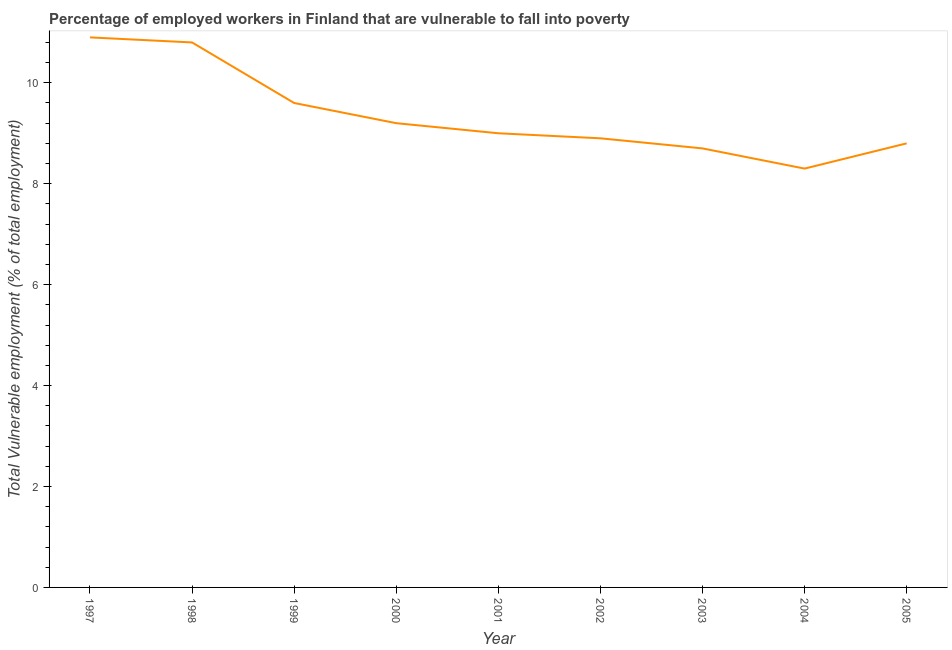Across all years, what is the maximum total vulnerable employment?
Provide a succinct answer. 10.9. Across all years, what is the minimum total vulnerable employment?
Your answer should be very brief. 8.3. What is the sum of the total vulnerable employment?
Provide a short and direct response. 84.2. What is the difference between the total vulnerable employment in 2003 and 2004?
Your answer should be compact. 0.4. What is the average total vulnerable employment per year?
Keep it short and to the point. 9.36. What is the median total vulnerable employment?
Give a very brief answer. 9. In how many years, is the total vulnerable employment greater than 9.2 %?
Make the answer very short. 3. Do a majority of the years between 1999 and 2002 (inclusive) have total vulnerable employment greater than 6.4 %?
Ensure brevity in your answer.  Yes. What is the ratio of the total vulnerable employment in 2000 to that in 2003?
Keep it short and to the point. 1.06. Is the difference between the total vulnerable employment in 1997 and 2002 greater than the difference between any two years?
Keep it short and to the point. No. What is the difference between the highest and the second highest total vulnerable employment?
Make the answer very short. 0.1. Is the sum of the total vulnerable employment in 1997 and 2001 greater than the maximum total vulnerable employment across all years?
Provide a succinct answer. Yes. What is the difference between the highest and the lowest total vulnerable employment?
Your response must be concise. 2.6. In how many years, is the total vulnerable employment greater than the average total vulnerable employment taken over all years?
Give a very brief answer. 3. How many lines are there?
Keep it short and to the point. 1. How many years are there in the graph?
Your answer should be very brief. 9. Are the values on the major ticks of Y-axis written in scientific E-notation?
Your answer should be compact. No. Does the graph contain any zero values?
Your answer should be very brief. No. What is the title of the graph?
Keep it short and to the point. Percentage of employed workers in Finland that are vulnerable to fall into poverty. What is the label or title of the Y-axis?
Provide a succinct answer. Total Vulnerable employment (% of total employment). What is the Total Vulnerable employment (% of total employment) in 1997?
Offer a very short reply. 10.9. What is the Total Vulnerable employment (% of total employment) of 1998?
Your answer should be compact. 10.8. What is the Total Vulnerable employment (% of total employment) of 1999?
Offer a very short reply. 9.6. What is the Total Vulnerable employment (% of total employment) in 2000?
Provide a short and direct response. 9.2. What is the Total Vulnerable employment (% of total employment) of 2001?
Your response must be concise. 9. What is the Total Vulnerable employment (% of total employment) of 2002?
Your answer should be very brief. 8.9. What is the Total Vulnerable employment (% of total employment) of 2003?
Offer a very short reply. 8.7. What is the Total Vulnerable employment (% of total employment) in 2004?
Provide a short and direct response. 8.3. What is the Total Vulnerable employment (% of total employment) of 2005?
Give a very brief answer. 8.8. What is the difference between the Total Vulnerable employment (% of total employment) in 1997 and 2000?
Provide a succinct answer. 1.7. What is the difference between the Total Vulnerable employment (% of total employment) in 1997 and 2001?
Give a very brief answer. 1.9. What is the difference between the Total Vulnerable employment (% of total employment) in 1997 and 2002?
Give a very brief answer. 2. What is the difference between the Total Vulnerable employment (% of total employment) in 1997 and 2004?
Your answer should be very brief. 2.6. What is the difference between the Total Vulnerable employment (% of total employment) in 1998 and 2000?
Keep it short and to the point. 1.6. What is the difference between the Total Vulnerable employment (% of total employment) in 1998 and 2001?
Your answer should be compact. 1.8. What is the difference between the Total Vulnerable employment (% of total employment) in 1998 and 2002?
Provide a short and direct response. 1.9. What is the difference between the Total Vulnerable employment (% of total employment) in 1998 and 2004?
Ensure brevity in your answer.  2.5. What is the difference between the Total Vulnerable employment (% of total employment) in 1999 and 2000?
Your response must be concise. 0.4. What is the difference between the Total Vulnerable employment (% of total employment) in 2000 and 2002?
Give a very brief answer. 0.3. What is the difference between the Total Vulnerable employment (% of total employment) in 2000 and 2004?
Offer a very short reply. 0.9. What is the difference between the Total Vulnerable employment (% of total employment) in 2001 and 2002?
Ensure brevity in your answer.  0.1. What is the difference between the Total Vulnerable employment (% of total employment) in 2001 and 2003?
Your answer should be very brief. 0.3. What is the difference between the Total Vulnerable employment (% of total employment) in 2001 and 2004?
Your response must be concise. 0.7. What is the difference between the Total Vulnerable employment (% of total employment) in 2002 and 2005?
Your response must be concise. 0.1. What is the difference between the Total Vulnerable employment (% of total employment) in 2004 and 2005?
Provide a succinct answer. -0.5. What is the ratio of the Total Vulnerable employment (% of total employment) in 1997 to that in 1999?
Ensure brevity in your answer.  1.14. What is the ratio of the Total Vulnerable employment (% of total employment) in 1997 to that in 2000?
Give a very brief answer. 1.19. What is the ratio of the Total Vulnerable employment (% of total employment) in 1997 to that in 2001?
Give a very brief answer. 1.21. What is the ratio of the Total Vulnerable employment (% of total employment) in 1997 to that in 2002?
Offer a terse response. 1.23. What is the ratio of the Total Vulnerable employment (% of total employment) in 1997 to that in 2003?
Your answer should be compact. 1.25. What is the ratio of the Total Vulnerable employment (% of total employment) in 1997 to that in 2004?
Your answer should be compact. 1.31. What is the ratio of the Total Vulnerable employment (% of total employment) in 1997 to that in 2005?
Your response must be concise. 1.24. What is the ratio of the Total Vulnerable employment (% of total employment) in 1998 to that in 1999?
Offer a terse response. 1.12. What is the ratio of the Total Vulnerable employment (% of total employment) in 1998 to that in 2000?
Your answer should be very brief. 1.17. What is the ratio of the Total Vulnerable employment (% of total employment) in 1998 to that in 2001?
Keep it short and to the point. 1.2. What is the ratio of the Total Vulnerable employment (% of total employment) in 1998 to that in 2002?
Offer a terse response. 1.21. What is the ratio of the Total Vulnerable employment (% of total employment) in 1998 to that in 2003?
Ensure brevity in your answer.  1.24. What is the ratio of the Total Vulnerable employment (% of total employment) in 1998 to that in 2004?
Provide a short and direct response. 1.3. What is the ratio of the Total Vulnerable employment (% of total employment) in 1998 to that in 2005?
Your answer should be compact. 1.23. What is the ratio of the Total Vulnerable employment (% of total employment) in 1999 to that in 2000?
Offer a terse response. 1.04. What is the ratio of the Total Vulnerable employment (% of total employment) in 1999 to that in 2001?
Offer a terse response. 1.07. What is the ratio of the Total Vulnerable employment (% of total employment) in 1999 to that in 2002?
Make the answer very short. 1.08. What is the ratio of the Total Vulnerable employment (% of total employment) in 1999 to that in 2003?
Provide a short and direct response. 1.1. What is the ratio of the Total Vulnerable employment (% of total employment) in 1999 to that in 2004?
Provide a succinct answer. 1.16. What is the ratio of the Total Vulnerable employment (% of total employment) in 1999 to that in 2005?
Your response must be concise. 1.09. What is the ratio of the Total Vulnerable employment (% of total employment) in 2000 to that in 2001?
Keep it short and to the point. 1.02. What is the ratio of the Total Vulnerable employment (% of total employment) in 2000 to that in 2002?
Make the answer very short. 1.03. What is the ratio of the Total Vulnerable employment (% of total employment) in 2000 to that in 2003?
Provide a short and direct response. 1.06. What is the ratio of the Total Vulnerable employment (% of total employment) in 2000 to that in 2004?
Your answer should be very brief. 1.11. What is the ratio of the Total Vulnerable employment (% of total employment) in 2000 to that in 2005?
Offer a terse response. 1.04. What is the ratio of the Total Vulnerable employment (% of total employment) in 2001 to that in 2002?
Provide a short and direct response. 1.01. What is the ratio of the Total Vulnerable employment (% of total employment) in 2001 to that in 2003?
Ensure brevity in your answer.  1.03. What is the ratio of the Total Vulnerable employment (% of total employment) in 2001 to that in 2004?
Provide a short and direct response. 1.08. What is the ratio of the Total Vulnerable employment (% of total employment) in 2002 to that in 2003?
Offer a terse response. 1.02. What is the ratio of the Total Vulnerable employment (% of total employment) in 2002 to that in 2004?
Provide a short and direct response. 1.07. What is the ratio of the Total Vulnerable employment (% of total employment) in 2003 to that in 2004?
Provide a succinct answer. 1.05. What is the ratio of the Total Vulnerable employment (% of total employment) in 2003 to that in 2005?
Provide a succinct answer. 0.99. What is the ratio of the Total Vulnerable employment (% of total employment) in 2004 to that in 2005?
Give a very brief answer. 0.94. 